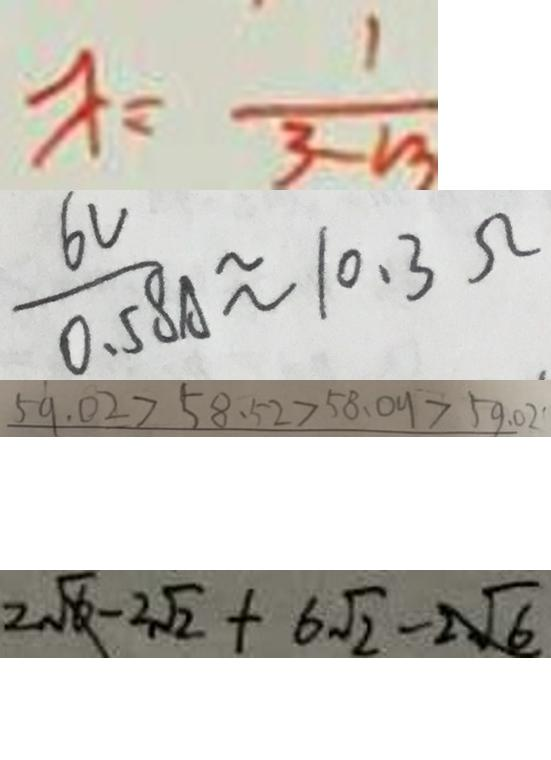Convert formula to latex. <formula><loc_0><loc_0><loc_500><loc_500>x = \frac { 1 } { 3 - m } 
 \frac { 6 V } { 0 . 5 8 A } \approx 1 0 . 3 \Omega 
 5 9 . 0 2 > 5 8 . 5 2 > 5 8 . 0 9 > 5 9 . 0 2 
 2 \sqrt { 6 } - 2 \sqrt { 2 } + 6 \sqrt { 2 } - 2 \sqrt { 6 }</formula> 